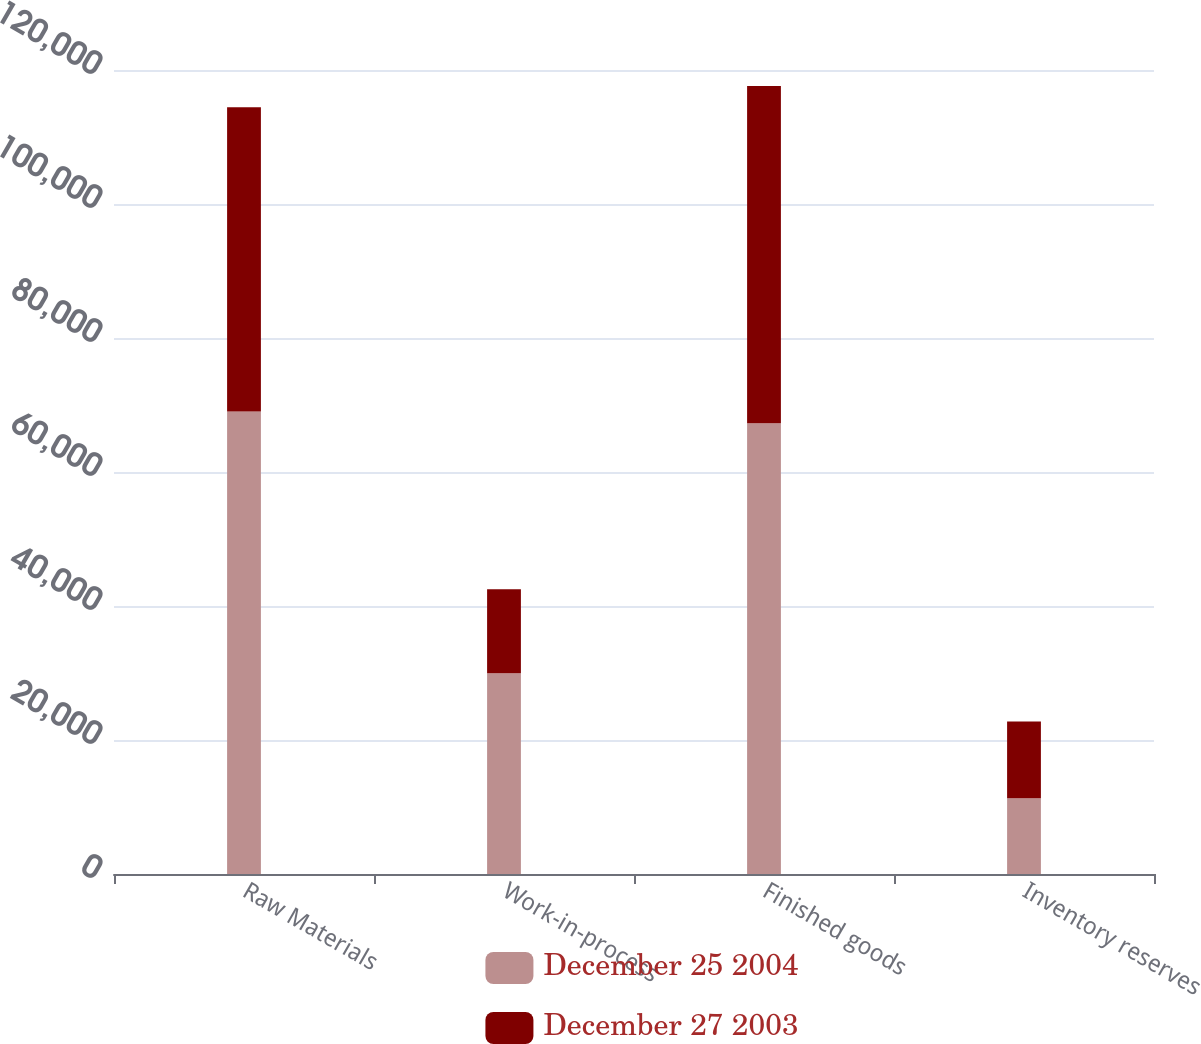<chart> <loc_0><loc_0><loc_500><loc_500><stacked_bar_chart><ecel><fcel>Raw Materials<fcel>Work-in-process<fcel>Finished goods<fcel>Inventory reserves<nl><fcel>December 25 2004<fcel>69036<fcel>29959<fcel>67274<fcel>11289<nl><fcel>December 27 2003<fcel>45388<fcel>12551<fcel>50340<fcel>11485<nl></chart> 